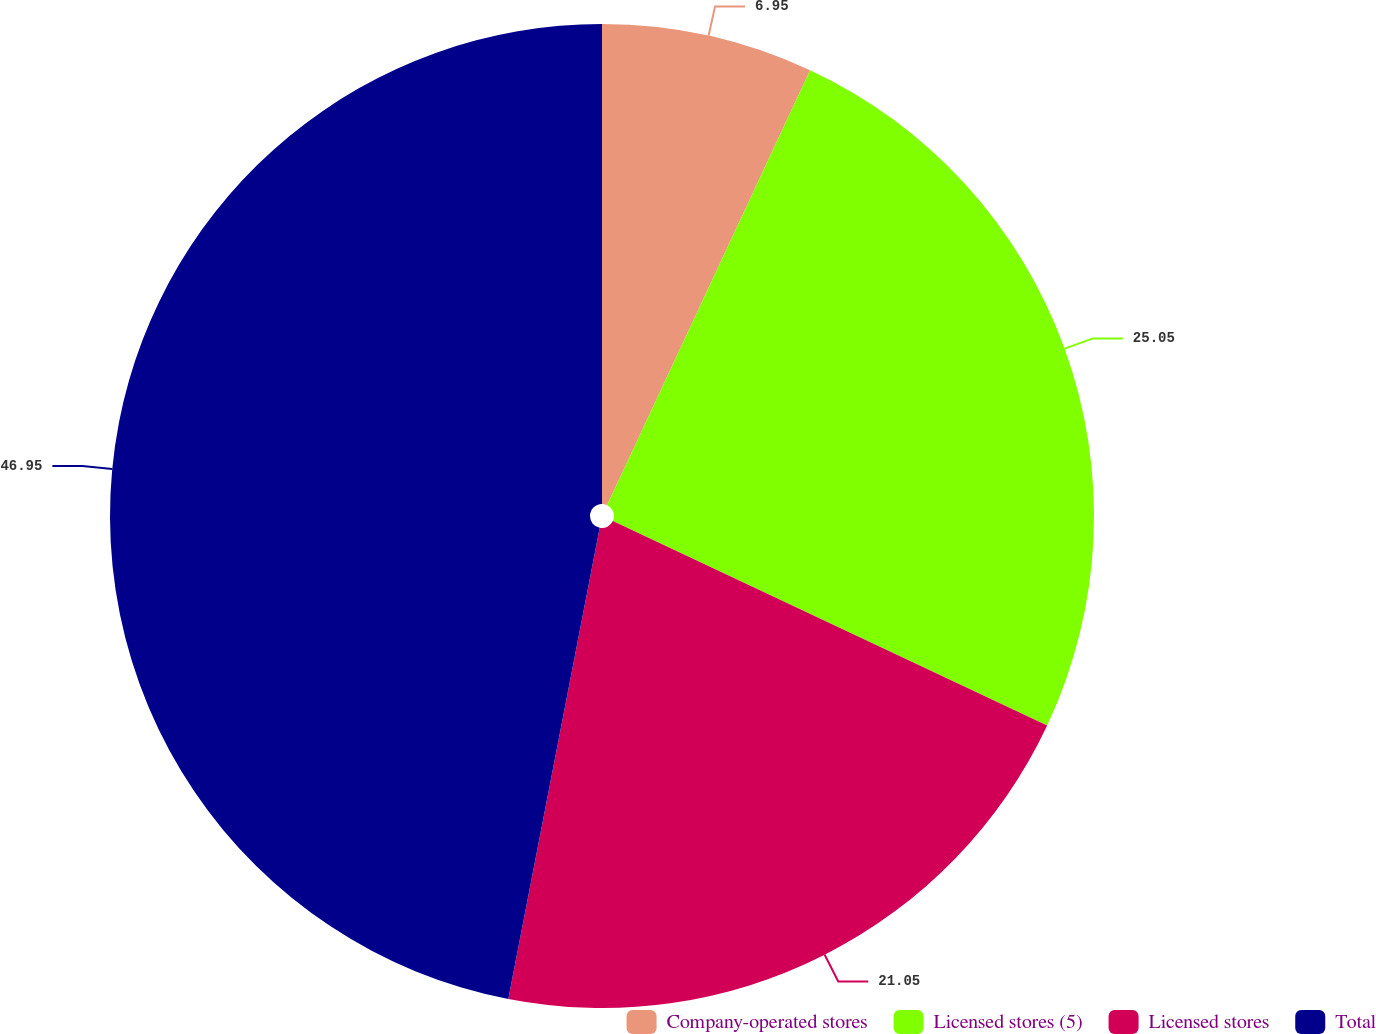Convert chart to OTSL. <chart><loc_0><loc_0><loc_500><loc_500><pie_chart><fcel>Company-operated stores<fcel>Licensed stores (5)<fcel>Licensed stores<fcel>Total<nl><fcel>6.95%<fcel>25.05%<fcel>21.05%<fcel>46.95%<nl></chart> 